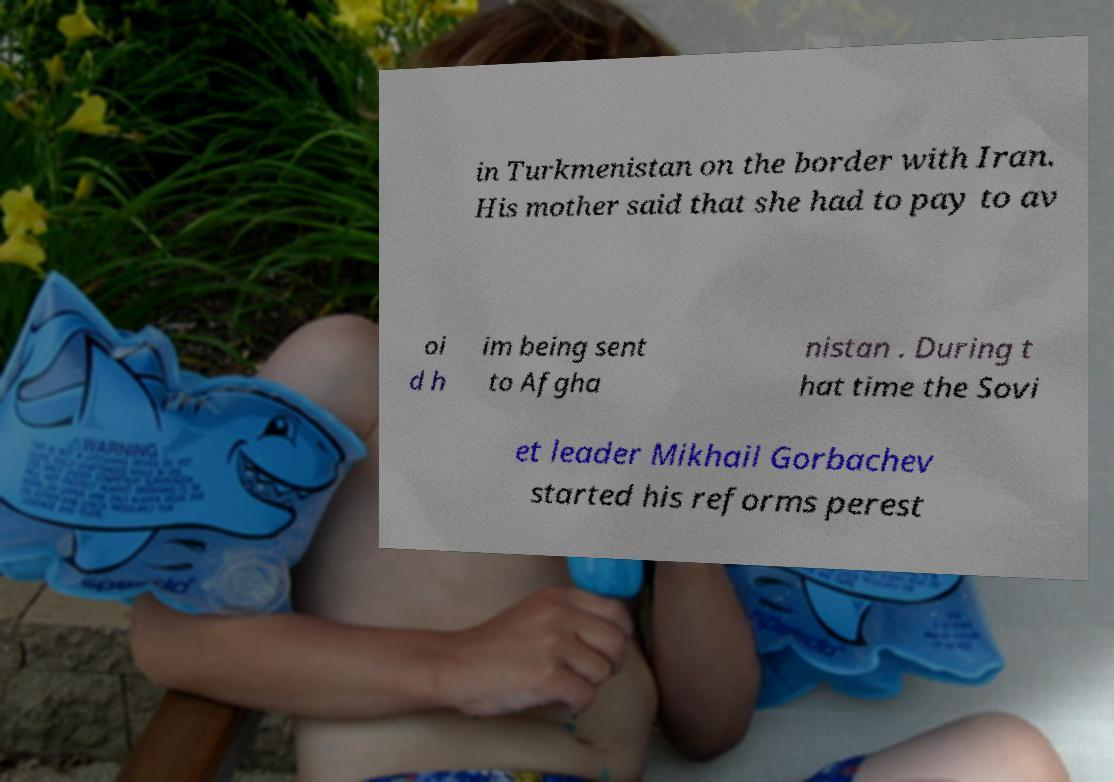There's text embedded in this image that I need extracted. Can you transcribe it verbatim? in Turkmenistan on the border with Iran. His mother said that she had to pay to av oi d h im being sent to Afgha nistan . During t hat time the Sovi et leader Mikhail Gorbachev started his reforms perest 